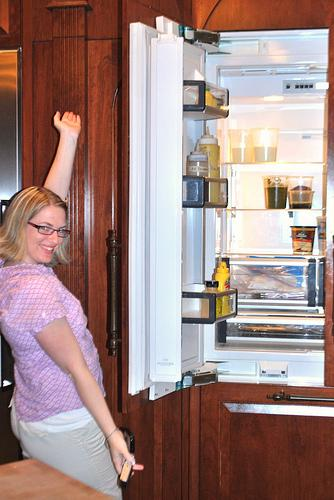Describe the setting of the image by mentioning the woman, the refrigerator, and the cabinet. A beaming woman with eyeglasses poses in a kitchen setting between an open refrigerator and a closed cabinet. Express the scene in a light-hearted manner by mentioning the woman and the refrigerator. A bespectacled woman is having a jolly time showcasing the contents of her bustling open refrigerator. Provide a concise description of the scene by mentioning the woman and the main object she is interacting with. A woman in glasses and a purple blouse is posing in front of an open refrigerator filled with various items. Briefly describe the situation in the image by mentioning the woman, the refrigerator, and its contents. A cheerful young lady wearing glasses is posing next to an open refrigerator filled with condiments, containers, and food. Mention the woman's action and what she is holding in her hand with descriptive words. A smiling young woman with raised arm is holding a silver item in her right hand near an open refrigerator. Create a vivid description of the woman and her surroundings by mentioning the main elements in the image. An enthusiastic woman with stylish glasses poses gleefully in front of a well-stocked refrigerator and a wooden counter. Describe the general scene in a poetic manner by mentioning the woman and the refrigerator. In a kitchen filled with warmth, a woman adorned with eyeglasses graces the open refrigerator with her gleaming smile. Highlight the woman's outfit and her interaction with the primary object in the scene. A young woman with a purple blouse, beige shorts, and glasses is cheerfully demonstrating her open refrigerator. Create a simple statement that describes the woman and her connection with the open refrigerator. A smiling woman, dressed in a purple blouse and glasses, stands near an open refrigerator full of items. Present a short yet descriptive sentence about the woman and her actions. A delightful young woman in glasses stands proudly next to her fully stocked open refrigerator. 